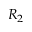Convert formula to latex. <formula><loc_0><loc_0><loc_500><loc_500>R _ { 2 }</formula> 